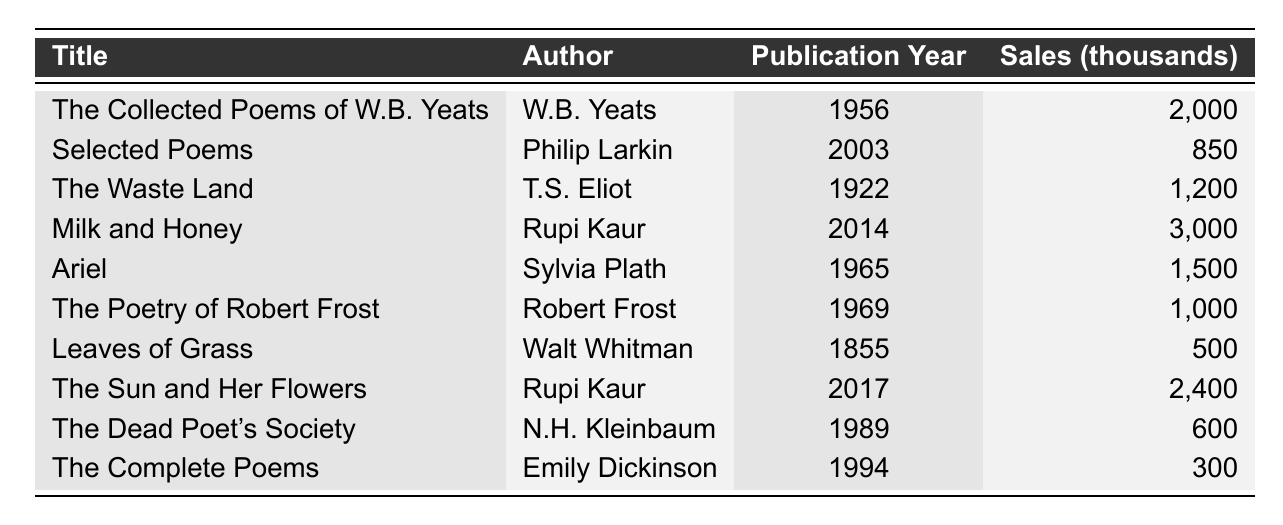What is the title of the poetry book with the highest sales figures? The table shows that "Milk and Honey" has the highest sales figures at 3,000 thousands.
Answer: Milk and Honey In what year was "The Waste Land" published? The table lists the publication year of "The Waste Land" as 1922.
Answer: 1922 Who is the author of "Ariel"? According to the table, "Ariel" was written by Sylvia Plath.
Answer: Sylvia Plath What are the sales figures for "The Complete Poems"? Referring to the table, "The Complete Poems" has sales figures of 300 thousands.
Answer: 300 How many poetry books were published before 1950? The table lists three books published before 1950: "Leaves of Grass" (1855), "The Waste Land" (1922), and "The Collected Poems of W.B. Yeats" (1956). Thus, there are three books.
Answer: 3 What is the average sales figure for the books authored by Rupi Kaur? Rupi Kaur has two books in the table: "Milk and Honey" with 3,000 thousands and "The Sun and Her Flowers" with 2,400 thousands. Summing them up gives 5,400 thousands, and dividing by 2 gives an average of 2,700 thousands.
Answer: 2700 Is the sales figure of "The Poetry of Robert Frost" greater than the sales figure of "Selected Poems"? "The Poetry of Robert Frost" has sales figures of 1,000 thousands while "Selected Poems" has 850 thousands. Since 1,000 > 850, the answer is yes.
Answer: Yes What is the difference in sales figures between "Milk and Honey" and "Ariel"? "Milk and Honey" has sales figures of 3,000 thousands while "Ariel" has 1,500 thousands. The difference is 3,000 - 1,500, which equals 1,500 thousands.
Answer: 1500 Which book has the lowest sales figures and what are they? The table indicates that "The Complete Poems" has the lowest sales figures of 300 thousands.
Answer: The Complete Poems, 300 How many authors have works listed in the table? The table lists ten different titles with unique authors, so there are ten authors in total.
Answer: 10 What percentage of the total sales do "The Sun and Her Flowers" contribute? The total sales equals 3,000 + 2,400 + 2,000 + 850 + 1,200 + 1,500 + 1,000 + 500 + 600 + 300 = 14,550 thousands. "The Sun and Her Flowers" sales figures are 2,400 thousands. The percentage is (2,400 / 14,550) * 100 ≈ 16.49%.
Answer: 16.49% 